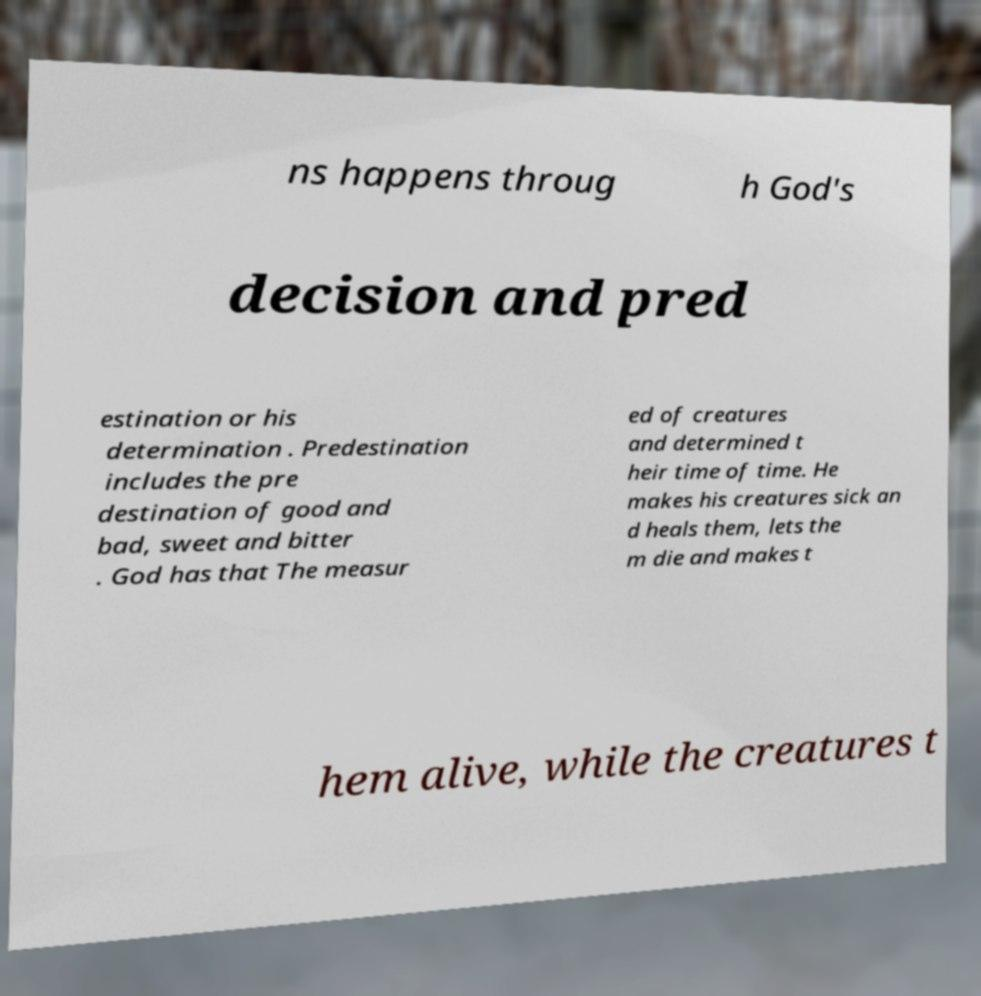Please identify and transcribe the text found in this image. ns happens throug h God's decision and pred estination or his determination . Predestination includes the pre destination of good and bad, sweet and bitter . God has that The measur ed of creatures and determined t heir time of time. He makes his creatures sick an d heals them, lets the m die and makes t hem alive, while the creatures t 